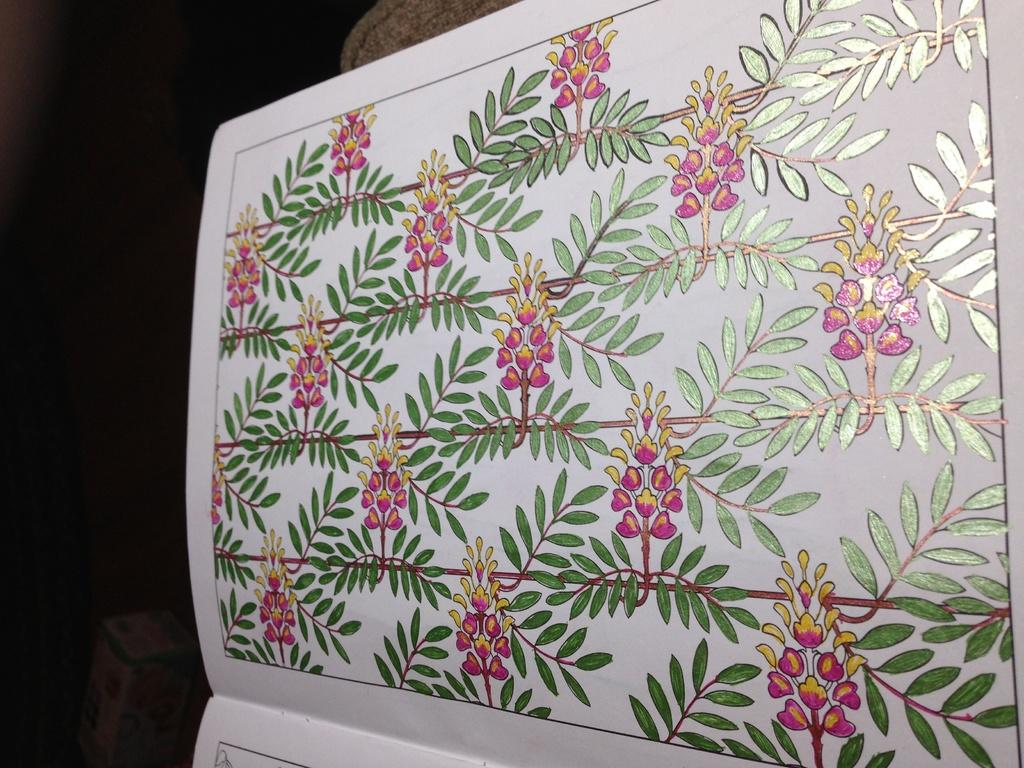What is the main object in the image? There is a book in the image. What is depicted on the paper in the image? The paper in the image has leaves and flowers depicted on it. Can you describe the object on the left side of the image? Unfortunately, the provided facts do not give enough information to describe the object on the left side of the image. What type of plate is being used to compare the airplane's performance in the image? There is no plate or airplane present in the image, so it is not possible to answer that question. 